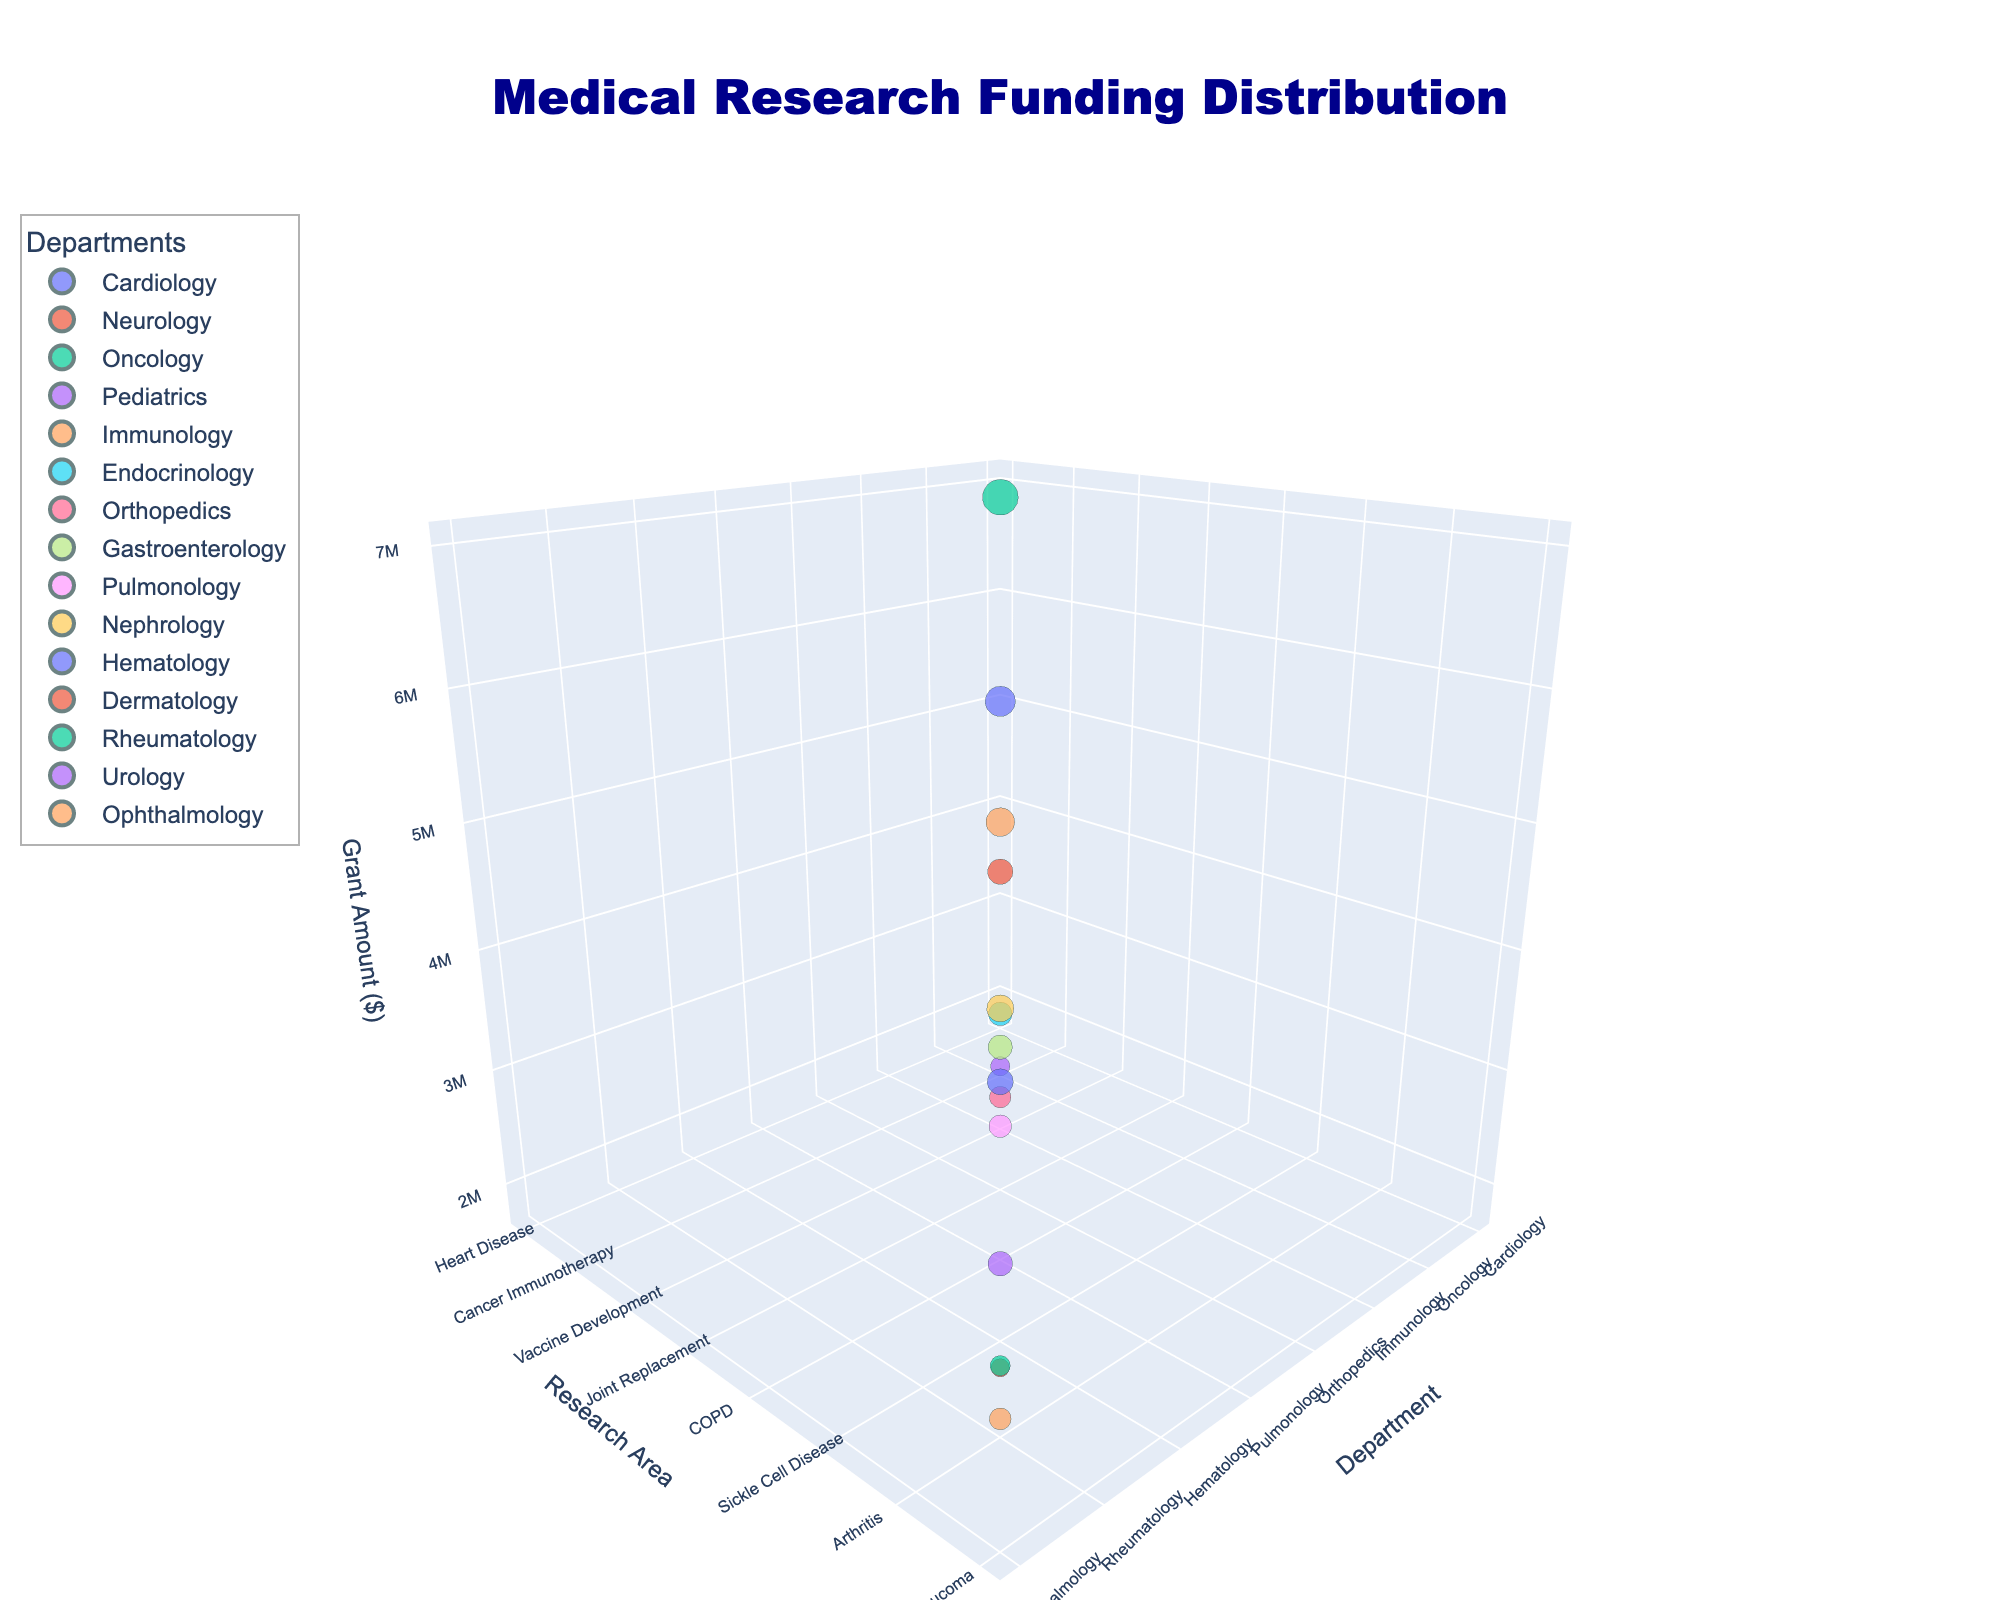What is the title of the chart? The title is located at the top of the chart and is labeled clearly.
Answer: Medical Research Funding Distribution Which department has the highest grant amount? Look for the largest bubble in the chart, as bubble size indicates grant amounts.
Answer: Oncology What are the research areas represented in the Neurology department? Look for the Neurology bubbles and read the y-axis labels corresponding to those points.
Answer: Alzheimer's Compare the grant amounts for Endocrinology (Diabetes) and Gastroenterology (Inflammatory Bowel Disease). Which one is greater? Identify the bubbles for Endocrinology and Gastroenterology, then compare their sizes or values on the z-axis.
Answer: Gastroenterology What is the total grant amount for Cardiology, Immunology, and Rheumatology? Find the grant amounts for each: Cardiology (Heart Disease) $5,000,000, Immunology (Vaccine Development) $4,500,000, and Rheumatology (Arthritis) $2,200,000. Add them together: $5,000,000 + $4,500,000 + $2,200,000 = $11,700,000.
Answer: $11,700,000 How many departments have grant amounts over $3,000,000? Identify and count the bubbles with grant amounts above $3,000,000.
Answer: 7 Which research area in Pediatrics is funded, and what is the grant amount? Look for the Pediatrics bubble and check the y-axis and z-axis labels.
Answer: Childhood Obesity, $2,000,000 Is the grant for Urology (Prostate Cancer) greater than that for Nephrology (Kidney Transplantation)? Compare the z-axis value for Urology and Nephrology.
Answer: No What is the average grant amount for Pulmonology, Nephrology, and Hematology? Find the grant amounts for Pulmonology (COPD) $2,800,000, Nephrology (Kidney Transplantation) $4,000,000, and Hematology (Sickle Cell Disease) $3,700,000. Add them and divide by 3: ($2,800,000 + $4,000,000 + $3,700,000) / 3 = $3,500,000.
Answer: $3,500,000 